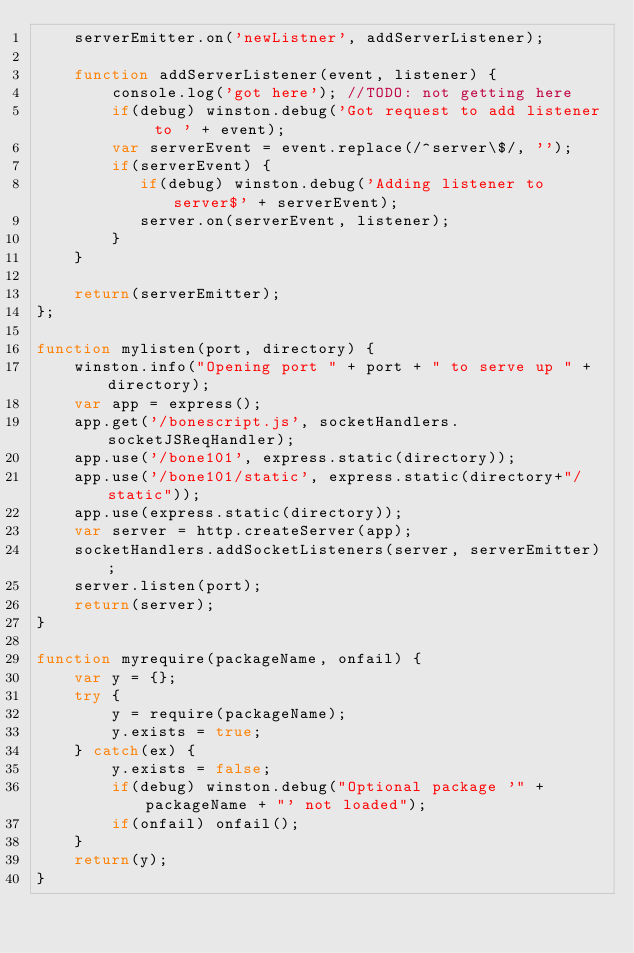<code> <loc_0><loc_0><loc_500><loc_500><_JavaScript_>    serverEmitter.on('newListner', addServerListener);

    function addServerListener(event, listener) {
        console.log('got here'); //TODO: not getting here
        if(debug) winston.debug('Got request to add listener to ' + event);
        var serverEvent = event.replace(/^server\$/, '');
        if(serverEvent) {
           if(debug) winston.debug('Adding listener to server$' + serverEvent);
           server.on(serverEvent, listener);
        }
    }

    return(serverEmitter);
};

function mylisten(port, directory) {
    winston.info("Opening port " + port + " to serve up " + directory);
    var app = express();
    app.get('/bonescript.js', socketHandlers.socketJSReqHandler);
    app.use('/bone101', express.static(directory));
    app.use('/bone101/static', express.static(directory+"/static"));
    app.use(express.static(directory));
    var server = http.createServer(app);
    socketHandlers.addSocketListeners(server, serverEmitter);
    server.listen(port);
    return(server);
}

function myrequire(packageName, onfail) {
    var y = {};
    try {
        y = require(packageName);
        y.exists = true;
    } catch(ex) {
        y.exists = false;
        if(debug) winston.debug("Optional package '" + packageName + "' not loaded");
        if(onfail) onfail();
    }
    return(y);
}
</code> 